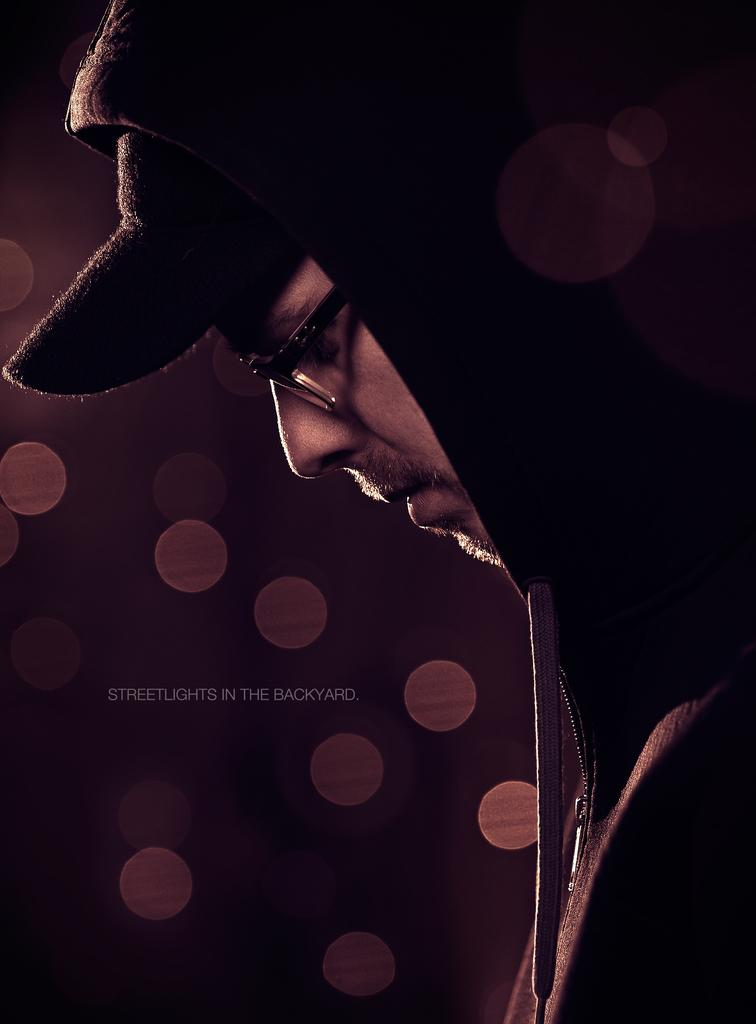Who is the main subject in the image? There is a man in the image. What type of clothing is the man wearing? The man is wearing a hoodie and a cap. Are there any accessories visible on the man? Yes, the man is wearing spectacles. Can you describe any additional features of the image? There is a watermark in the image. What type of eggnog is the man holding in the image? There is no eggnog present in the image; the man is not holding any beverage. Can you see a rake in the image? There is no rake present in the image. 